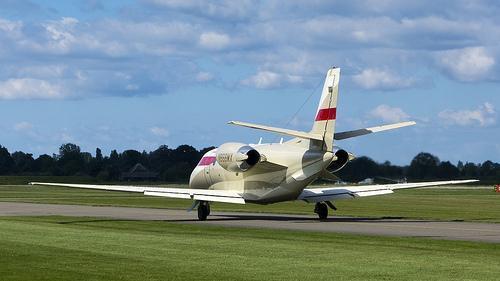How many planes are in the photo?
Give a very brief answer. 1. 